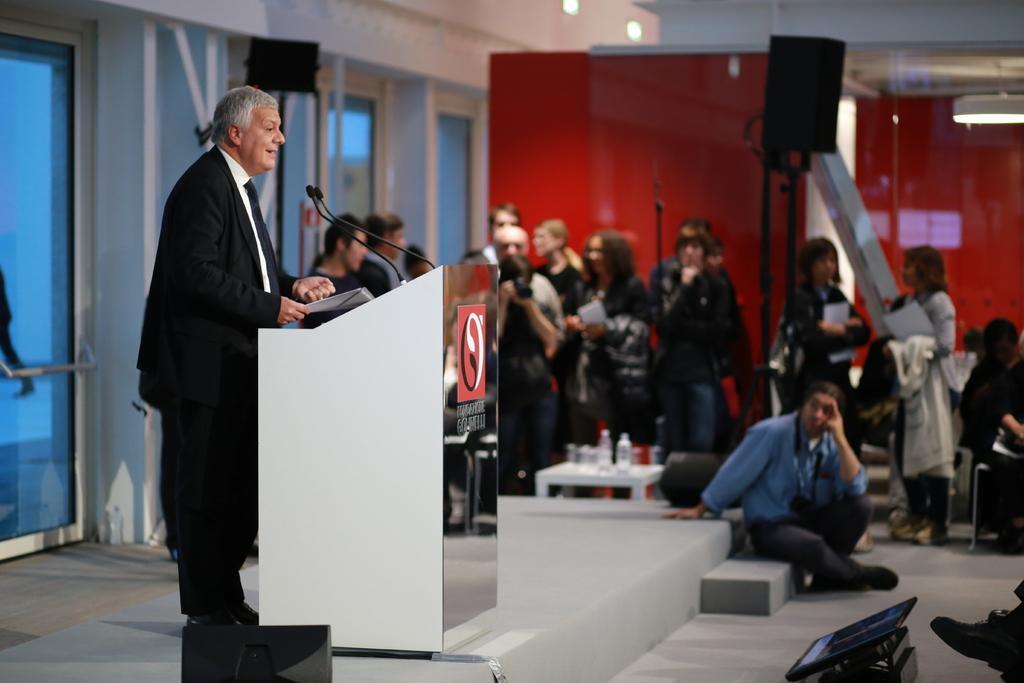Could you give a brief overview of what you see in this image? In the center of the image there is a person standing near a podium. In the background of the image there are people. To the left side of the image there are glass doors. At the top of the image there is a ceiling. 